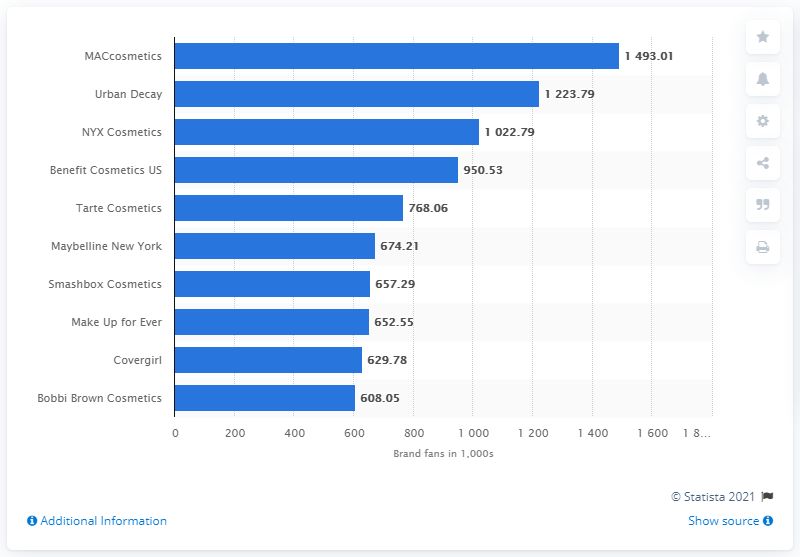Identify some key points in this picture. In July 2018, Tarte Cosmetics was the fifth most popular beauty brand on Twitter, according to data available. 